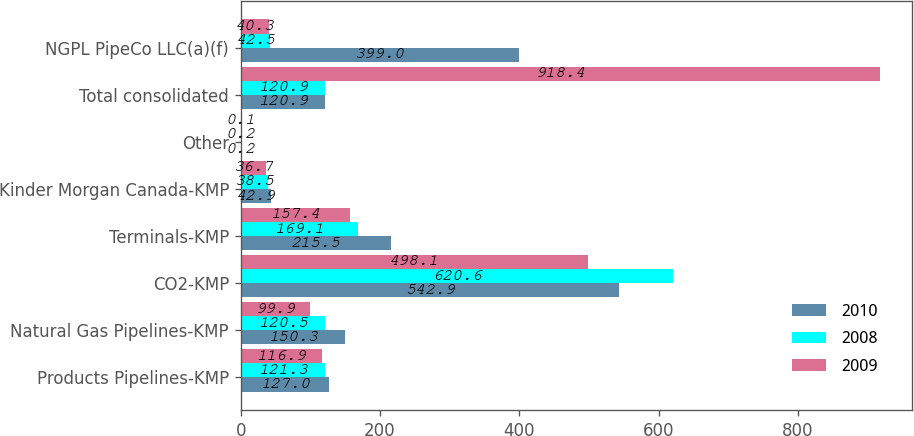Convert chart to OTSL. <chart><loc_0><loc_0><loc_500><loc_500><stacked_bar_chart><ecel><fcel>Products Pipelines-KMP<fcel>Natural Gas Pipelines-KMP<fcel>CO2-KMP<fcel>Terminals-KMP<fcel>Kinder Morgan Canada-KMP<fcel>Other<fcel>Total consolidated<fcel>NGPL PipeCo LLC(a)(f)<nl><fcel>2010<fcel>127<fcel>150.3<fcel>542.9<fcel>215.5<fcel>42.9<fcel>0.2<fcel>120.9<fcel>399<nl><fcel>2008<fcel>121.3<fcel>120.5<fcel>620.6<fcel>169.1<fcel>38.5<fcel>0.2<fcel>120.9<fcel>42.5<nl><fcel>2009<fcel>116.9<fcel>99.9<fcel>498.1<fcel>157.4<fcel>36.7<fcel>0.1<fcel>918.4<fcel>40.3<nl></chart> 